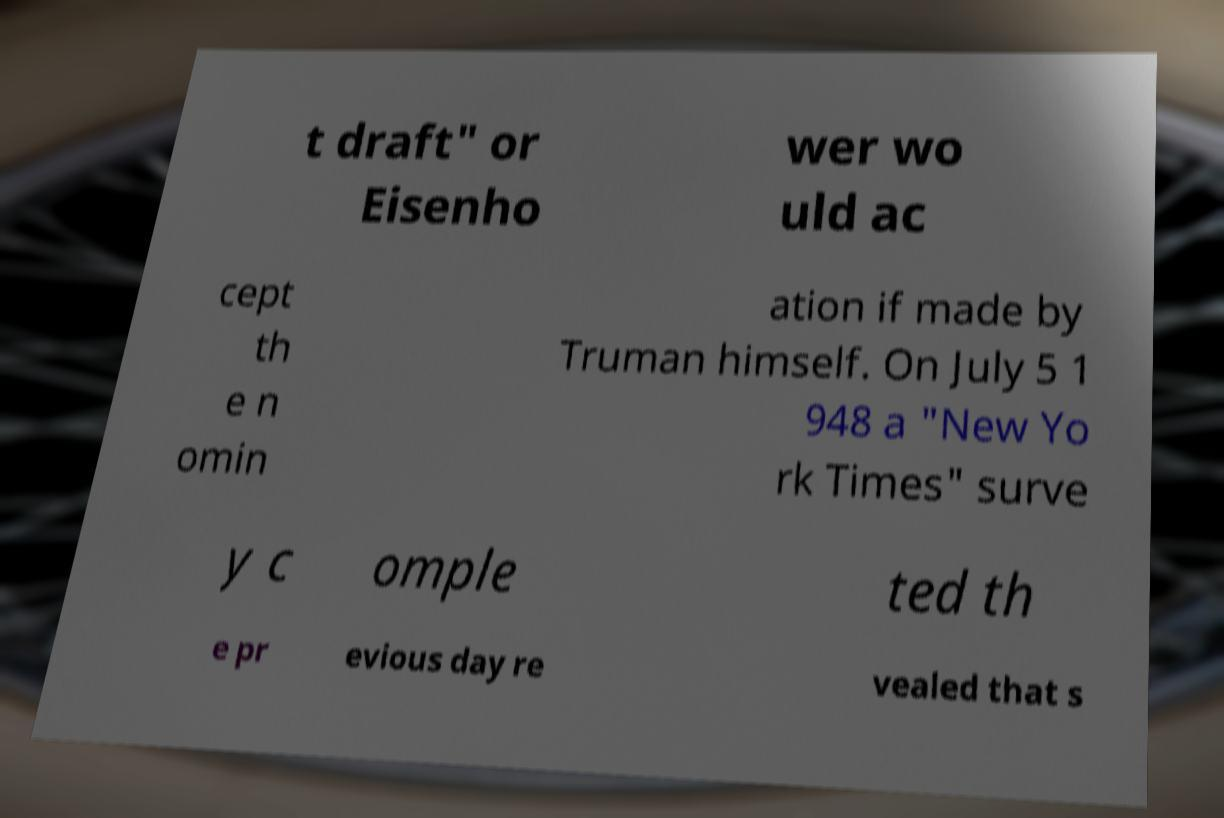Please read and relay the text visible in this image. What does it say? t draft" or Eisenho wer wo uld ac cept th e n omin ation if made by Truman himself. On July 5 1 948 a "New Yo rk Times" surve y c omple ted th e pr evious day re vealed that s 